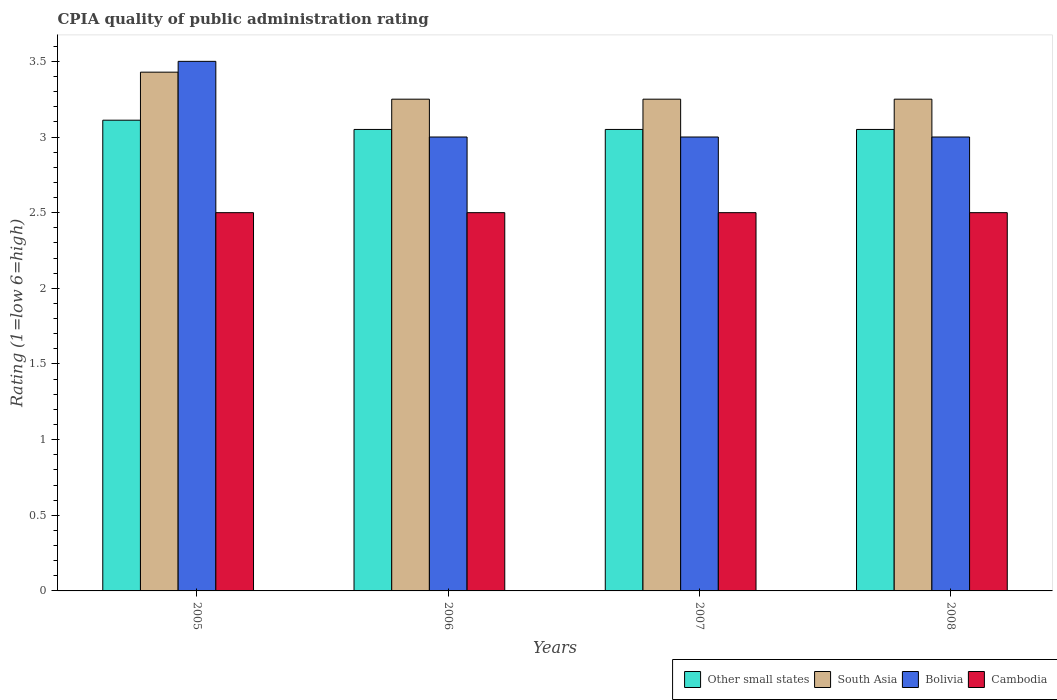Are the number of bars per tick equal to the number of legend labels?
Offer a very short reply. Yes. What is the label of the 3rd group of bars from the left?
Your response must be concise. 2007. Across all years, what is the maximum CPIA rating in South Asia?
Offer a terse response. 3.43. Across all years, what is the minimum CPIA rating in South Asia?
Provide a short and direct response. 3.25. What is the total CPIA rating in Cambodia in the graph?
Your answer should be very brief. 10. What is the difference between the CPIA rating in Bolivia in 2008 and the CPIA rating in Other small states in 2007?
Your answer should be compact. -0.05. What is the average CPIA rating in Other small states per year?
Offer a terse response. 3.07. In the year 2007, what is the difference between the CPIA rating in Bolivia and CPIA rating in Cambodia?
Provide a short and direct response. 0.5. In how many years, is the CPIA rating in Other small states greater than 3?
Offer a terse response. 4. Is the CPIA rating in Bolivia in 2005 less than that in 2008?
Offer a very short reply. No. What is the difference between the highest and the lowest CPIA rating in South Asia?
Offer a terse response. 0.18. In how many years, is the CPIA rating in Other small states greater than the average CPIA rating in Other small states taken over all years?
Offer a terse response. 1. Is it the case that in every year, the sum of the CPIA rating in South Asia and CPIA rating in Bolivia is greater than the sum of CPIA rating in Other small states and CPIA rating in Cambodia?
Your response must be concise. Yes. What does the 1st bar from the left in 2008 represents?
Offer a terse response. Other small states. Is it the case that in every year, the sum of the CPIA rating in Bolivia and CPIA rating in Cambodia is greater than the CPIA rating in Other small states?
Give a very brief answer. Yes. How many years are there in the graph?
Ensure brevity in your answer.  4. Does the graph contain grids?
Ensure brevity in your answer.  No. Where does the legend appear in the graph?
Give a very brief answer. Bottom right. What is the title of the graph?
Provide a succinct answer. CPIA quality of public administration rating. What is the Rating (1=low 6=high) of Other small states in 2005?
Give a very brief answer. 3.11. What is the Rating (1=low 6=high) in South Asia in 2005?
Provide a succinct answer. 3.43. What is the Rating (1=low 6=high) of Cambodia in 2005?
Offer a very short reply. 2.5. What is the Rating (1=low 6=high) in Other small states in 2006?
Give a very brief answer. 3.05. What is the Rating (1=low 6=high) of Other small states in 2007?
Your answer should be very brief. 3.05. What is the Rating (1=low 6=high) in Cambodia in 2007?
Offer a terse response. 2.5. What is the Rating (1=low 6=high) in Other small states in 2008?
Make the answer very short. 3.05. What is the Rating (1=low 6=high) in Bolivia in 2008?
Your response must be concise. 3. What is the Rating (1=low 6=high) in Cambodia in 2008?
Your answer should be compact. 2.5. Across all years, what is the maximum Rating (1=low 6=high) in Other small states?
Ensure brevity in your answer.  3.11. Across all years, what is the maximum Rating (1=low 6=high) in South Asia?
Provide a short and direct response. 3.43. Across all years, what is the maximum Rating (1=low 6=high) in Bolivia?
Provide a short and direct response. 3.5. Across all years, what is the maximum Rating (1=low 6=high) in Cambodia?
Your answer should be very brief. 2.5. Across all years, what is the minimum Rating (1=low 6=high) of Other small states?
Provide a succinct answer. 3.05. Across all years, what is the minimum Rating (1=low 6=high) of Bolivia?
Make the answer very short. 3. What is the total Rating (1=low 6=high) of Other small states in the graph?
Keep it short and to the point. 12.26. What is the total Rating (1=low 6=high) of South Asia in the graph?
Your answer should be very brief. 13.18. What is the total Rating (1=low 6=high) of Bolivia in the graph?
Give a very brief answer. 12.5. What is the difference between the Rating (1=low 6=high) of Other small states in 2005 and that in 2006?
Provide a short and direct response. 0.06. What is the difference between the Rating (1=low 6=high) of South Asia in 2005 and that in 2006?
Give a very brief answer. 0.18. What is the difference between the Rating (1=low 6=high) in Bolivia in 2005 and that in 2006?
Offer a very short reply. 0.5. What is the difference between the Rating (1=low 6=high) of Cambodia in 2005 and that in 2006?
Provide a succinct answer. 0. What is the difference between the Rating (1=low 6=high) in Other small states in 2005 and that in 2007?
Make the answer very short. 0.06. What is the difference between the Rating (1=low 6=high) of South Asia in 2005 and that in 2007?
Your answer should be compact. 0.18. What is the difference between the Rating (1=low 6=high) in Other small states in 2005 and that in 2008?
Your response must be concise. 0.06. What is the difference between the Rating (1=low 6=high) of South Asia in 2005 and that in 2008?
Make the answer very short. 0.18. What is the difference between the Rating (1=low 6=high) of Bolivia in 2005 and that in 2008?
Keep it short and to the point. 0.5. What is the difference between the Rating (1=low 6=high) in Cambodia in 2005 and that in 2008?
Your answer should be compact. 0. What is the difference between the Rating (1=low 6=high) in Other small states in 2006 and that in 2007?
Your answer should be very brief. 0. What is the difference between the Rating (1=low 6=high) of South Asia in 2006 and that in 2007?
Your response must be concise. 0. What is the difference between the Rating (1=low 6=high) in Cambodia in 2006 and that in 2007?
Your response must be concise. 0. What is the difference between the Rating (1=low 6=high) in South Asia in 2006 and that in 2008?
Offer a very short reply. 0. What is the difference between the Rating (1=low 6=high) in Cambodia in 2006 and that in 2008?
Offer a very short reply. 0. What is the difference between the Rating (1=low 6=high) in Other small states in 2007 and that in 2008?
Keep it short and to the point. 0. What is the difference between the Rating (1=low 6=high) of South Asia in 2007 and that in 2008?
Provide a succinct answer. 0. What is the difference between the Rating (1=low 6=high) of Cambodia in 2007 and that in 2008?
Provide a succinct answer. 0. What is the difference between the Rating (1=low 6=high) in Other small states in 2005 and the Rating (1=low 6=high) in South Asia in 2006?
Provide a succinct answer. -0.14. What is the difference between the Rating (1=low 6=high) in Other small states in 2005 and the Rating (1=low 6=high) in Cambodia in 2006?
Keep it short and to the point. 0.61. What is the difference between the Rating (1=low 6=high) of South Asia in 2005 and the Rating (1=low 6=high) of Bolivia in 2006?
Offer a very short reply. 0.43. What is the difference between the Rating (1=low 6=high) of Other small states in 2005 and the Rating (1=low 6=high) of South Asia in 2007?
Make the answer very short. -0.14. What is the difference between the Rating (1=low 6=high) in Other small states in 2005 and the Rating (1=low 6=high) in Cambodia in 2007?
Provide a short and direct response. 0.61. What is the difference between the Rating (1=low 6=high) in South Asia in 2005 and the Rating (1=low 6=high) in Bolivia in 2007?
Provide a succinct answer. 0.43. What is the difference between the Rating (1=low 6=high) in Other small states in 2005 and the Rating (1=low 6=high) in South Asia in 2008?
Give a very brief answer. -0.14. What is the difference between the Rating (1=low 6=high) in Other small states in 2005 and the Rating (1=low 6=high) in Bolivia in 2008?
Keep it short and to the point. 0.11. What is the difference between the Rating (1=low 6=high) in Other small states in 2005 and the Rating (1=low 6=high) in Cambodia in 2008?
Your answer should be compact. 0.61. What is the difference between the Rating (1=low 6=high) of South Asia in 2005 and the Rating (1=low 6=high) of Bolivia in 2008?
Make the answer very short. 0.43. What is the difference between the Rating (1=low 6=high) of South Asia in 2005 and the Rating (1=low 6=high) of Cambodia in 2008?
Offer a terse response. 0.93. What is the difference between the Rating (1=low 6=high) in Bolivia in 2005 and the Rating (1=low 6=high) in Cambodia in 2008?
Make the answer very short. 1. What is the difference between the Rating (1=low 6=high) in Other small states in 2006 and the Rating (1=low 6=high) in Cambodia in 2007?
Keep it short and to the point. 0.55. What is the difference between the Rating (1=low 6=high) in South Asia in 2006 and the Rating (1=low 6=high) in Cambodia in 2007?
Offer a very short reply. 0.75. What is the difference between the Rating (1=low 6=high) of Bolivia in 2006 and the Rating (1=low 6=high) of Cambodia in 2007?
Offer a terse response. 0.5. What is the difference between the Rating (1=low 6=high) of Other small states in 2006 and the Rating (1=low 6=high) of Bolivia in 2008?
Your answer should be very brief. 0.05. What is the difference between the Rating (1=low 6=high) in Other small states in 2006 and the Rating (1=low 6=high) in Cambodia in 2008?
Your answer should be very brief. 0.55. What is the difference between the Rating (1=low 6=high) of South Asia in 2006 and the Rating (1=low 6=high) of Bolivia in 2008?
Ensure brevity in your answer.  0.25. What is the difference between the Rating (1=low 6=high) of South Asia in 2006 and the Rating (1=low 6=high) of Cambodia in 2008?
Ensure brevity in your answer.  0.75. What is the difference between the Rating (1=low 6=high) of Other small states in 2007 and the Rating (1=low 6=high) of Bolivia in 2008?
Offer a very short reply. 0.05. What is the difference between the Rating (1=low 6=high) in Other small states in 2007 and the Rating (1=low 6=high) in Cambodia in 2008?
Offer a very short reply. 0.55. What is the difference between the Rating (1=low 6=high) of South Asia in 2007 and the Rating (1=low 6=high) of Bolivia in 2008?
Keep it short and to the point. 0.25. What is the difference between the Rating (1=low 6=high) of Bolivia in 2007 and the Rating (1=low 6=high) of Cambodia in 2008?
Offer a terse response. 0.5. What is the average Rating (1=low 6=high) of Other small states per year?
Offer a terse response. 3.07. What is the average Rating (1=low 6=high) of South Asia per year?
Offer a terse response. 3.29. What is the average Rating (1=low 6=high) of Bolivia per year?
Keep it short and to the point. 3.12. What is the average Rating (1=low 6=high) of Cambodia per year?
Make the answer very short. 2.5. In the year 2005, what is the difference between the Rating (1=low 6=high) of Other small states and Rating (1=low 6=high) of South Asia?
Offer a terse response. -0.32. In the year 2005, what is the difference between the Rating (1=low 6=high) in Other small states and Rating (1=low 6=high) in Bolivia?
Give a very brief answer. -0.39. In the year 2005, what is the difference between the Rating (1=low 6=high) in Other small states and Rating (1=low 6=high) in Cambodia?
Ensure brevity in your answer.  0.61. In the year 2005, what is the difference between the Rating (1=low 6=high) of South Asia and Rating (1=low 6=high) of Bolivia?
Your answer should be compact. -0.07. In the year 2005, what is the difference between the Rating (1=low 6=high) of South Asia and Rating (1=low 6=high) of Cambodia?
Offer a terse response. 0.93. In the year 2006, what is the difference between the Rating (1=low 6=high) of Other small states and Rating (1=low 6=high) of South Asia?
Make the answer very short. -0.2. In the year 2006, what is the difference between the Rating (1=low 6=high) in Other small states and Rating (1=low 6=high) in Bolivia?
Your answer should be very brief. 0.05. In the year 2006, what is the difference between the Rating (1=low 6=high) of Other small states and Rating (1=low 6=high) of Cambodia?
Your answer should be compact. 0.55. In the year 2007, what is the difference between the Rating (1=low 6=high) in Other small states and Rating (1=low 6=high) in South Asia?
Offer a very short reply. -0.2. In the year 2007, what is the difference between the Rating (1=low 6=high) in Other small states and Rating (1=low 6=high) in Cambodia?
Your answer should be very brief. 0.55. In the year 2007, what is the difference between the Rating (1=low 6=high) in South Asia and Rating (1=low 6=high) in Cambodia?
Offer a terse response. 0.75. In the year 2007, what is the difference between the Rating (1=low 6=high) in Bolivia and Rating (1=low 6=high) in Cambodia?
Your answer should be very brief. 0.5. In the year 2008, what is the difference between the Rating (1=low 6=high) in Other small states and Rating (1=low 6=high) in Cambodia?
Offer a terse response. 0.55. In the year 2008, what is the difference between the Rating (1=low 6=high) in South Asia and Rating (1=low 6=high) in Cambodia?
Make the answer very short. 0.75. In the year 2008, what is the difference between the Rating (1=low 6=high) of Bolivia and Rating (1=low 6=high) of Cambodia?
Provide a succinct answer. 0.5. What is the ratio of the Rating (1=low 6=high) of Other small states in 2005 to that in 2006?
Provide a succinct answer. 1.02. What is the ratio of the Rating (1=low 6=high) in South Asia in 2005 to that in 2006?
Offer a very short reply. 1.05. What is the ratio of the Rating (1=low 6=high) in South Asia in 2005 to that in 2007?
Offer a terse response. 1.05. What is the ratio of the Rating (1=low 6=high) of Bolivia in 2005 to that in 2007?
Give a very brief answer. 1.17. What is the ratio of the Rating (1=low 6=high) of Other small states in 2005 to that in 2008?
Provide a succinct answer. 1.02. What is the ratio of the Rating (1=low 6=high) of South Asia in 2005 to that in 2008?
Give a very brief answer. 1.05. What is the ratio of the Rating (1=low 6=high) of Cambodia in 2005 to that in 2008?
Provide a succinct answer. 1. What is the ratio of the Rating (1=low 6=high) in Other small states in 2006 to that in 2007?
Make the answer very short. 1. What is the ratio of the Rating (1=low 6=high) of South Asia in 2006 to that in 2007?
Provide a succinct answer. 1. What is the ratio of the Rating (1=low 6=high) in Other small states in 2006 to that in 2008?
Your answer should be very brief. 1. What is the ratio of the Rating (1=low 6=high) in Bolivia in 2006 to that in 2008?
Make the answer very short. 1. What is the ratio of the Rating (1=low 6=high) of Cambodia in 2006 to that in 2008?
Offer a terse response. 1. What is the ratio of the Rating (1=low 6=high) of Bolivia in 2007 to that in 2008?
Give a very brief answer. 1. What is the difference between the highest and the second highest Rating (1=low 6=high) of Other small states?
Your answer should be very brief. 0.06. What is the difference between the highest and the second highest Rating (1=low 6=high) in South Asia?
Offer a very short reply. 0.18. What is the difference between the highest and the second highest Rating (1=low 6=high) in Cambodia?
Keep it short and to the point. 0. What is the difference between the highest and the lowest Rating (1=low 6=high) of Other small states?
Offer a very short reply. 0.06. What is the difference between the highest and the lowest Rating (1=low 6=high) in South Asia?
Ensure brevity in your answer.  0.18. What is the difference between the highest and the lowest Rating (1=low 6=high) of Bolivia?
Offer a terse response. 0.5. What is the difference between the highest and the lowest Rating (1=low 6=high) in Cambodia?
Your answer should be compact. 0. 